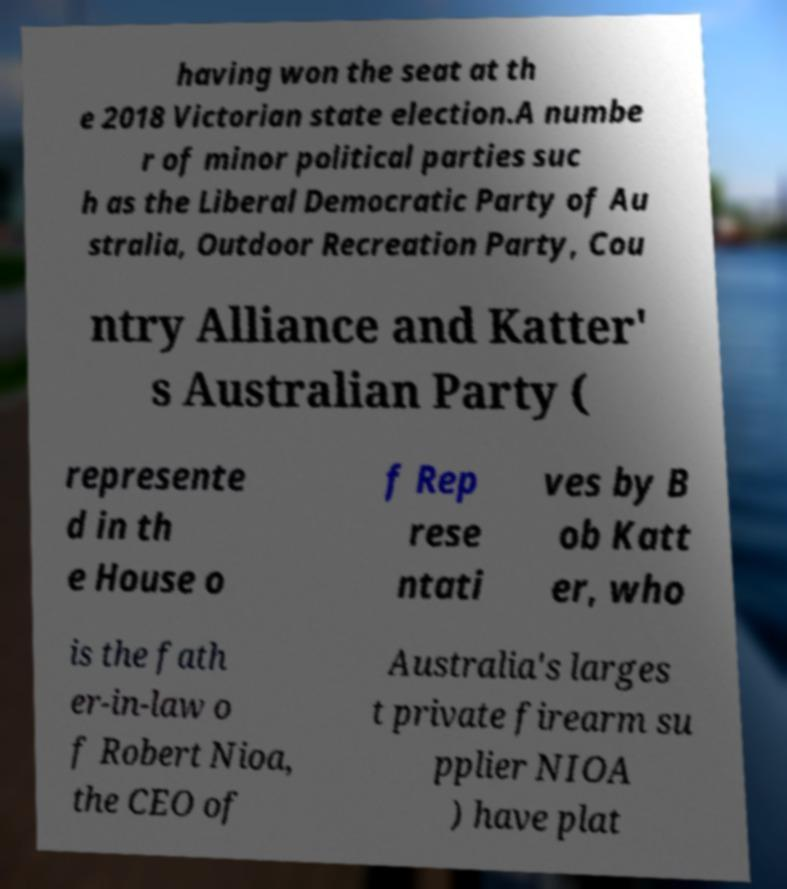Can you accurately transcribe the text from the provided image for me? having won the seat at th e 2018 Victorian state election.A numbe r of minor political parties suc h as the Liberal Democratic Party of Au stralia, Outdoor Recreation Party, Cou ntry Alliance and Katter' s Australian Party ( represente d in th e House o f Rep rese ntati ves by B ob Katt er, who is the fath er-in-law o f Robert Nioa, the CEO of Australia's larges t private firearm su pplier NIOA ) have plat 